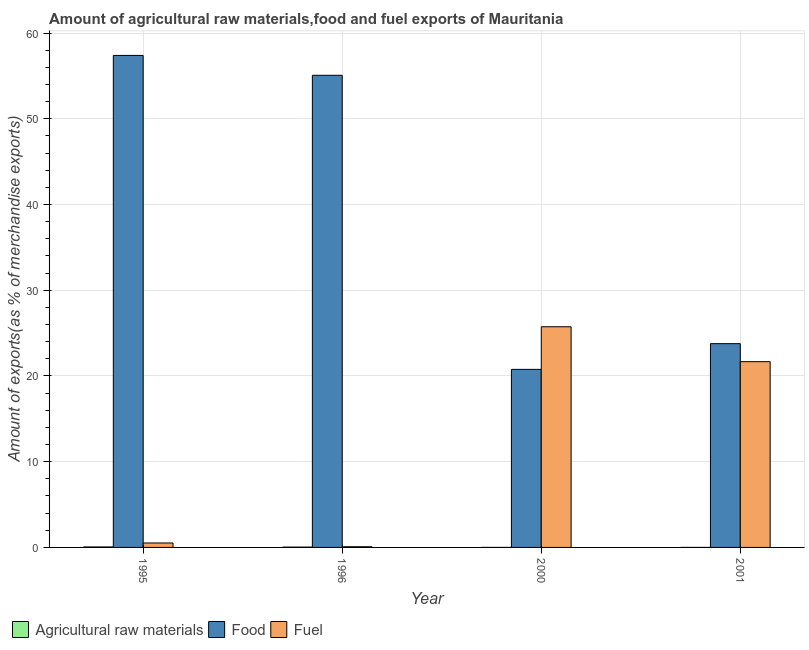How many different coloured bars are there?
Your answer should be very brief. 3. How many groups of bars are there?
Ensure brevity in your answer.  4. Are the number of bars per tick equal to the number of legend labels?
Offer a terse response. Yes. How many bars are there on the 2nd tick from the left?
Your response must be concise. 3. What is the percentage of food exports in 1995?
Offer a terse response. 57.4. Across all years, what is the maximum percentage of food exports?
Provide a short and direct response. 57.4. Across all years, what is the minimum percentage of fuel exports?
Offer a very short reply. 0.08. In which year was the percentage of raw materials exports maximum?
Give a very brief answer. 1995. What is the total percentage of fuel exports in the graph?
Offer a very short reply. 48.02. What is the difference between the percentage of raw materials exports in 1996 and that in 2000?
Make the answer very short. 0.03. What is the difference between the percentage of raw materials exports in 2000 and the percentage of food exports in 2001?
Your answer should be very brief. -0. What is the average percentage of food exports per year?
Your answer should be compact. 39.26. What is the ratio of the percentage of fuel exports in 2000 to that in 2001?
Keep it short and to the point. 1.19. What is the difference between the highest and the second highest percentage of food exports?
Offer a very short reply. 2.32. What is the difference between the highest and the lowest percentage of fuel exports?
Ensure brevity in your answer.  25.66. What does the 1st bar from the left in 1996 represents?
Your answer should be very brief. Agricultural raw materials. What does the 1st bar from the right in 1995 represents?
Provide a succinct answer. Fuel. Is it the case that in every year, the sum of the percentage of raw materials exports and percentage of food exports is greater than the percentage of fuel exports?
Make the answer very short. No. How many bars are there?
Ensure brevity in your answer.  12. Are all the bars in the graph horizontal?
Ensure brevity in your answer.  No. Does the graph contain any zero values?
Ensure brevity in your answer.  No. Where does the legend appear in the graph?
Provide a short and direct response. Bottom left. How are the legend labels stacked?
Keep it short and to the point. Horizontal. What is the title of the graph?
Ensure brevity in your answer.  Amount of agricultural raw materials,food and fuel exports of Mauritania. Does "Unemployment benefits" appear as one of the legend labels in the graph?
Provide a short and direct response. No. What is the label or title of the Y-axis?
Ensure brevity in your answer.  Amount of exports(as % of merchandise exports). What is the Amount of exports(as % of merchandise exports) of Agricultural raw materials in 1995?
Offer a terse response. 0.06. What is the Amount of exports(as % of merchandise exports) in Food in 1995?
Your answer should be compact. 57.4. What is the Amount of exports(as % of merchandise exports) in Fuel in 1995?
Provide a succinct answer. 0.52. What is the Amount of exports(as % of merchandise exports) in Agricultural raw materials in 1996?
Offer a terse response. 0.04. What is the Amount of exports(as % of merchandise exports) of Food in 1996?
Provide a short and direct response. 55.08. What is the Amount of exports(as % of merchandise exports) of Fuel in 1996?
Keep it short and to the point. 0.08. What is the Amount of exports(as % of merchandise exports) in Agricultural raw materials in 2000?
Provide a succinct answer. 0. What is the Amount of exports(as % of merchandise exports) of Food in 2000?
Make the answer very short. 20.77. What is the Amount of exports(as % of merchandise exports) in Fuel in 2000?
Give a very brief answer. 25.74. What is the Amount of exports(as % of merchandise exports) of Agricultural raw materials in 2001?
Give a very brief answer. 0. What is the Amount of exports(as % of merchandise exports) in Food in 2001?
Your answer should be compact. 23.77. What is the Amount of exports(as % of merchandise exports) of Fuel in 2001?
Ensure brevity in your answer.  21.67. Across all years, what is the maximum Amount of exports(as % of merchandise exports) in Agricultural raw materials?
Your answer should be compact. 0.06. Across all years, what is the maximum Amount of exports(as % of merchandise exports) of Food?
Offer a very short reply. 57.4. Across all years, what is the maximum Amount of exports(as % of merchandise exports) in Fuel?
Make the answer very short. 25.74. Across all years, what is the minimum Amount of exports(as % of merchandise exports) in Agricultural raw materials?
Your answer should be very brief. 0. Across all years, what is the minimum Amount of exports(as % of merchandise exports) of Food?
Your response must be concise. 20.77. Across all years, what is the minimum Amount of exports(as % of merchandise exports) in Fuel?
Offer a terse response. 0.08. What is the total Amount of exports(as % of merchandise exports) of Agricultural raw materials in the graph?
Provide a succinct answer. 0.09. What is the total Amount of exports(as % of merchandise exports) of Food in the graph?
Provide a short and direct response. 157.03. What is the total Amount of exports(as % of merchandise exports) in Fuel in the graph?
Provide a short and direct response. 48.02. What is the difference between the Amount of exports(as % of merchandise exports) in Agricultural raw materials in 1995 and that in 1996?
Make the answer very short. 0.02. What is the difference between the Amount of exports(as % of merchandise exports) of Food in 1995 and that in 1996?
Ensure brevity in your answer.  2.32. What is the difference between the Amount of exports(as % of merchandise exports) of Fuel in 1995 and that in 1996?
Provide a succinct answer. 0.44. What is the difference between the Amount of exports(as % of merchandise exports) in Agricultural raw materials in 1995 and that in 2000?
Offer a very short reply. 0.06. What is the difference between the Amount of exports(as % of merchandise exports) of Food in 1995 and that in 2000?
Offer a very short reply. 36.63. What is the difference between the Amount of exports(as % of merchandise exports) of Fuel in 1995 and that in 2000?
Provide a short and direct response. -25.23. What is the difference between the Amount of exports(as % of merchandise exports) in Agricultural raw materials in 1995 and that in 2001?
Your response must be concise. 0.05. What is the difference between the Amount of exports(as % of merchandise exports) of Food in 1995 and that in 2001?
Ensure brevity in your answer.  33.62. What is the difference between the Amount of exports(as % of merchandise exports) in Fuel in 1995 and that in 2001?
Provide a succinct answer. -21.15. What is the difference between the Amount of exports(as % of merchandise exports) of Agricultural raw materials in 1996 and that in 2000?
Offer a terse response. 0.03. What is the difference between the Amount of exports(as % of merchandise exports) in Food in 1996 and that in 2000?
Provide a succinct answer. 34.31. What is the difference between the Amount of exports(as % of merchandise exports) in Fuel in 1996 and that in 2000?
Offer a very short reply. -25.66. What is the difference between the Amount of exports(as % of merchandise exports) of Agricultural raw materials in 1996 and that in 2001?
Give a very brief answer. 0.03. What is the difference between the Amount of exports(as % of merchandise exports) in Food in 1996 and that in 2001?
Your response must be concise. 31.31. What is the difference between the Amount of exports(as % of merchandise exports) in Fuel in 1996 and that in 2001?
Offer a terse response. -21.59. What is the difference between the Amount of exports(as % of merchandise exports) of Agricultural raw materials in 2000 and that in 2001?
Offer a very short reply. -0. What is the difference between the Amount of exports(as % of merchandise exports) in Food in 2000 and that in 2001?
Your response must be concise. -3. What is the difference between the Amount of exports(as % of merchandise exports) of Fuel in 2000 and that in 2001?
Keep it short and to the point. 4.07. What is the difference between the Amount of exports(as % of merchandise exports) in Agricultural raw materials in 1995 and the Amount of exports(as % of merchandise exports) in Food in 1996?
Provide a short and direct response. -55.02. What is the difference between the Amount of exports(as % of merchandise exports) of Agricultural raw materials in 1995 and the Amount of exports(as % of merchandise exports) of Fuel in 1996?
Keep it short and to the point. -0.02. What is the difference between the Amount of exports(as % of merchandise exports) of Food in 1995 and the Amount of exports(as % of merchandise exports) of Fuel in 1996?
Offer a very short reply. 57.32. What is the difference between the Amount of exports(as % of merchandise exports) in Agricultural raw materials in 1995 and the Amount of exports(as % of merchandise exports) in Food in 2000?
Provide a succinct answer. -20.72. What is the difference between the Amount of exports(as % of merchandise exports) of Agricultural raw materials in 1995 and the Amount of exports(as % of merchandise exports) of Fuel in 2000?
Keep it short and to the point. -25.69. What is the difference between the Amount of exports(as % of merchandise exports) in Food in 1995 and the Amount of exports(as % of merchandise exports) in Fuel in 2000?
Ensure brevity in your answer.  31.65. What is the difference between the Amount of exports(as % of merchandise exports) of Agricultural raw materials in 1995 and the Amount of exports(as % of merchandise exports) of Food in 2001?
Provide a succinct answer. -23.72. What is the difference between the Amount of exports(as % of merchandise exports) in Agricultural raw materials in 1995 and the Amount of exports(as % of merchandise exports) in Fuel in 2001?
Provide a short and direct response. -21.62. What is the difference between the Amount of exports(as % of merchandise exports) of Food in 1995 and the Amount of exports(as % of merchandise exports) of Fuel in 2001?
Give a very brief answer. 35.73. What is the difference between the Amount of exports(as % of merchandise exports) of Agricultural raw materials in 1996 and the Amount of exports(as % of merchandise exports) of Food in 2000?
Your answer should be very brief. -20.74. What is the difference between the Amount of exports(as % of merchandise exports) of Agricultural raw materials in 1996 and the Amount of exports(as % of merchandise exports) of Fuel in 2000?
Give a very brief answer. -25.71. What is the difference between the Amount of exports(as % of merchandise exports) of Food in 1996 and the Amount of exports(as % of merchandise exports) of Fuel in 2000?
Your answer should be very brief. 29.34. What is the difference between the Amount of exports(as % of merchandise exports) in Agricultural raw materials in 1996 and the Amount of exports(as % of merchandise exports) in Food in 2001?
Make the answer very short. -23.74. What is the difference between the Amount of exports(as % of merchandise exports) of Agricultural raw materials in 1996 and the Amount of exports(as % of merchandise exports) of Fuel in 2001?
Your response must be concise. -21.64. What is the difference between the Amount of exports(as % of merchandise exports) in Food in 1996 and the Amount of exports(as % of merchandise exports) in Fuel in 2001?
Your response must be concise. 33.41. What is the difference between the Amount of exports(as % of merchandise exports) of Agricultural raw materials in 2000 and the Amount of exports(as % of merchandise exports) of Food in 2001?
Offer a very short reply. -23.77. What is the difference between the Amount of exports(as % of merchandise exports) of Agricultural raw materials in 2000 and the Amount of exports(as % of merchandise exports) of Fuel in 2001?
Provide a short and direct response. -21.67. What is the difference between the Amount of exports(as % of merchandise exports) in Food in 2000 and the Amount of exports(as % of merchandise exports) in Fuel in 2001?
Keep it short and to the point. -0.9. What is the average Amount of exports(as % of merchandise exports) of Agricultural raw materials per year?
Make the answer very short. 0.02. What is the average Amount of exports(as % of merchandise exports) in Food per year?
Offer a terse response. 39.26. What is the average Amount of exports(as % of merchandise exports) of Fuel per year?
Offer a very short reply. 12. In the year 1995, what is the difference between the Amount of exports(as % of merchandise exports) of Agricultural raw materials and Amount of exports(as % of merchandise exports) of Food?
Your answer should be compact. -57.34. In the year 1995, what is the difference between the Amount of exports(as % of merchandise exports) in Agricultural raw materials and Amount of exports(as % of merchandise exports) in Fuel?
Ensure brevity in your answer.  -0.46. In the year 1995, what is the difference between the Amount of exports(as % of merchandise exports) of Food and Amount of exports(as % of merchandise exports) of Fuel?
Offer a very short reply. 56.88. In the year 1996, what is the difference between the Amount of exports(as % of merchandise exports) in Agricultural raw materials and Amount of exports(as % of merchandise exports) in Food?
Provide a succinct answer. -55.04. In the year 1996, what is the difference between the Amount of exports(as % of merchandise exports) of Agricultural raw materials and Amount of exports(as % of merchandise exports) of Fuel?
Offer a terse response. -0.04. In the year 1996, what is the difference between the Amount of exports(as % of merchandise exports) in Food and Amount of exports(as % of merchandise exports) in Fuel?
Your answer should be very brief. 55. In the year 2000, what is the difference between the Amount of exports(as % of merchandise exports) in Agricultural raw materials and Amount of exports(as % of merchandise exports) in Food?
Provide a succinct answer. -20.77. In the year 2000, what is the difference between the Amount of exports(as % of merchandise exports) in Agricultural raw materials and Amount of exports(as % of merchandise exports) in Fuel?
Your answer should be very brief. -25.74. In the year 2000, what is the difference between the Amount of exports(as % of merchandise exports) in Food and Amount of exports(as % of merchandise exports) in Fuel?
Offer a very short reply. -4.97. In the year 2001, what is the difference between the Amount of exports(as % of merchandise exports) in Agricultural raw materials and Amount of exports(as % of merchandise exports) in Food?
Your answer should be compact. -23.77. In the year 2001, what is the difference between the Amount of exports(as % of merchandise exports) in Agricultural raw materials and Amount of exports(as % of merchandise exports) in Fuel?
Offer a very short reply. -21.67. In the year 2001, what is the difference between the Amount of exports(as % of merchandise exports) of Food and Amount of exports(as % of merchandise exports) of Fuel?
Ensure brevity in your answer.  2.1. What is the ratio of the Amount of exports(as % of merchandise exports) of Agricultural raw materials in 1995 to that in 1996?
Your answer should be compact. 1.6. What is the ratio of the Amount of exports(as % of merchandise exports) of Food in 1995 to that in 1996?
Provide a succinct answer. 1.04. What is the ratio of the Amount of exports(as % of merchandise exports) of Fuel in 1995 to that in 1996?
Your answer should be very brief. 6.51. What is the ratio of the Amount of exports(as % of merchandise exports) of Agricultural raw materials in 1995 to that in 2000?
Ensure brevity in your answer.  62.6. What is the ratio of the Amount of exports(as % of merchandise exports) of Food in 1995 to that in 2000?
Your answer should be very brief. 2.76. What is the ratio of the Amount of exports(as % of merchandise exports) of Fuel in 1995 to that in 2000?
Provide a short and direct response. 0.02. What is the ratio of the Amount of exports(as % of merchandise exports) in Agricultural raw materials in 1995 to that in 2001?
Provide a succinct answer. 31.88. What is the ratio of the Amount of exports(as % of merchandise exports) of Food in 1995 to that in 2001?
Your response must be concise. 2.41. What is the ratio of the Amount of exports(as % of merchandise exports) of Fuel in 1995 to that in 2001?
Provide a succinct answer. 0.02. What is the ratio of the Amount of exports(as % of merchandise exports) in Agricultural raw materials in 1996 to that in 2000?
Give a very brief answer. 39.09. What is the ratio of the Amount of exports(as % of merchandise exports) of Food in 1996 to that in 2000?
Your answer should be very brief. 2.65. What is the ratio of the Amount of exports(as % of merchandise exports) of Fuel in 1996 to that in 2000?
Provide a succinct answer. 0. What is the ratio of the Amount of exports(as % of merchandise exports) of Agricultural raw materials in 1996 to that in 2001?
Offer a terse response. 19.91. What is the ratio of the Amount of exports(as % of merchandise exports) in Food in 1996 to that in 2001?
Your answer should be very brief. 2.32. What is the ratio of the Amount of exports(as % of merchandise exports) of Fuel in 1996 to that in 2001?
Offer a terse response. 0. What is the ratio of the Amount of exports(as % of merchandise exports) in Agricultural raw materials in 2000 to that in 2001?
Ensure brevity in your answer.  0.51. What is the ratio of the Amount of exports(as % of merchandise exports) in Food in 2000 to that in 2001?
Give a very brief answer. 0.87. What is the ratio of the Amount of exports(as % of merchandise exports) of Fuel in 2000 to that in 2001?
Provide a succinct answer. 1.19. What is the difference between the highest and the second highest Amount of exports(as % of merchandise exports) of Agricultural raw materials?
Your response must be concise. 0.02. What is the difference between the highest and the second highest Amount of exports(as % of merchandise exports) of Food?
Give a very brief answer. 2.32. What is the difference between the highest and the second highest Amount of exports(as % of merchandise exports) of Fuel?
Offer a very short reply. 4.07. What is the difference between the highest and the lowest Amount of exports(as % of merchandise exports) of Agricultural raw materials?
Offer a very short reply. 0.06. What is the difference between the highest and the lowest Amount of exports(as % of merchandise exports) of Food?
Your answer should be very brief. 36.63. What is the difference between the highest and the lowest Amount of exports(as % of merchandise exports) in Fuel?
Your answer should be compact. 25.66. 